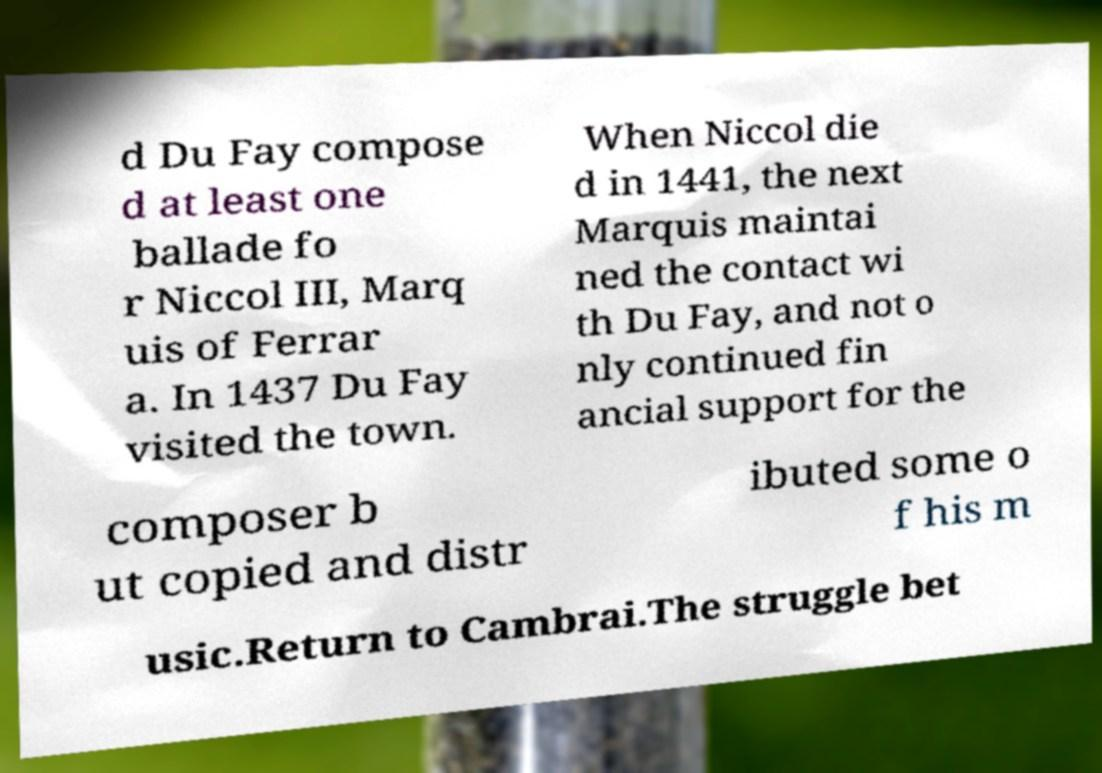Could you assist in decoding the text presented in this image and type it out clearly? d Du Fay compose d at least one ballade fo r Niccol III, Marq uis of Ferrar a. In 1437 Du Fay visited the town. When Niccol die d in 1441, the next Marquis maintai ned the contact wi th Du Fay, and not o nly continued fin ancial support for the composer b ut copied and distr ibuted some o f his m usic.Return to Cambrai.The struggle bet 